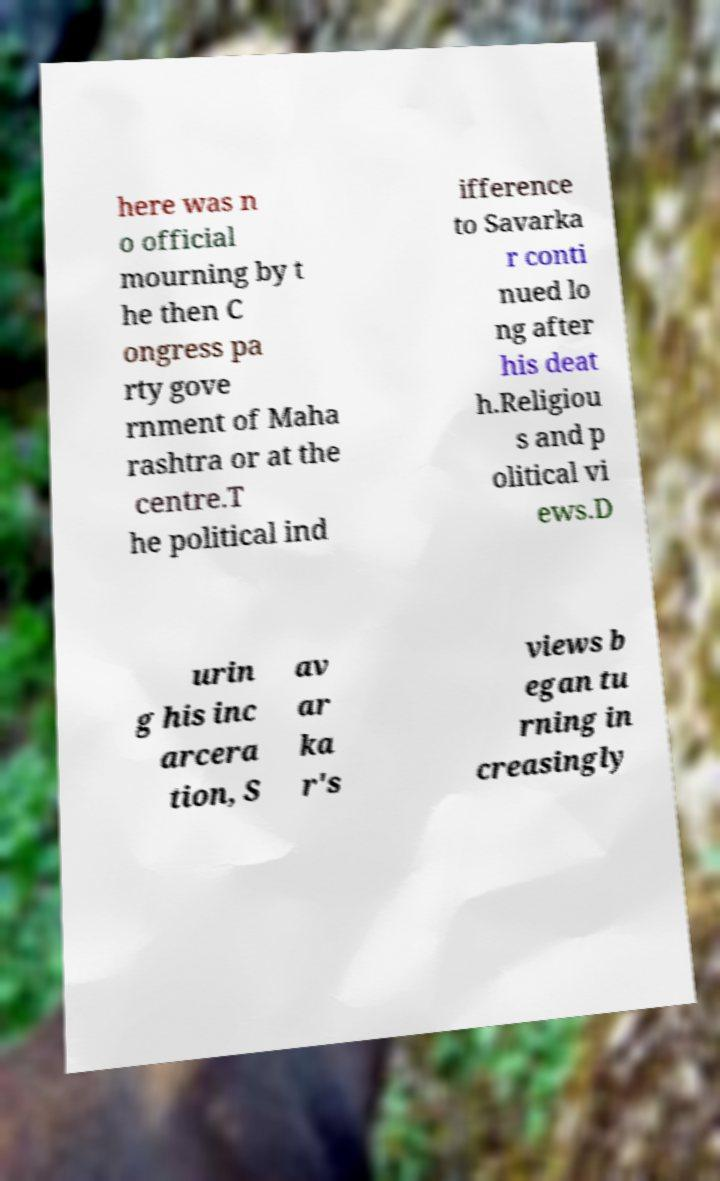Could you assist in decoding the text presented in this image and type it out clearly? here was n o official mourning by t he then C ongress pa rty gove rnment of Maha rashtra or at the centre.T he political ind ifference to Savarka r conti nued lo ng after his deat h.Religiou s and p olitical vi ews.D urin g his inc arcera tion, S av ar ka r's views b egan tu rning in creasingly 